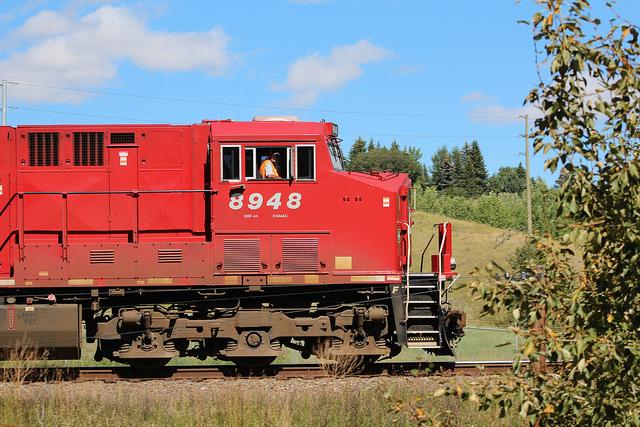What number is printed on the train?
Answer briefly. 8948. How many people are in the window of the train?
Answer briefly. 1. How many steps do you see on the front of the train?
Write a very short answer. 5. 